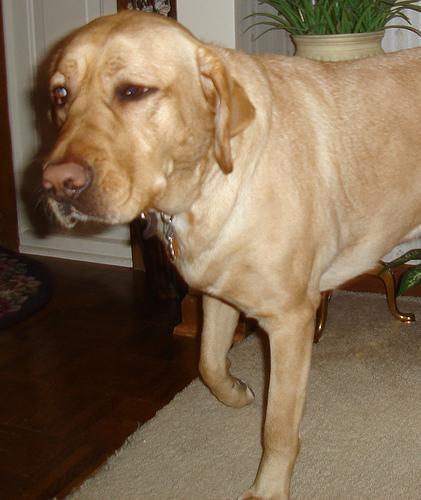How many dogs are in the picture?
Give a very brief answer. 1. 